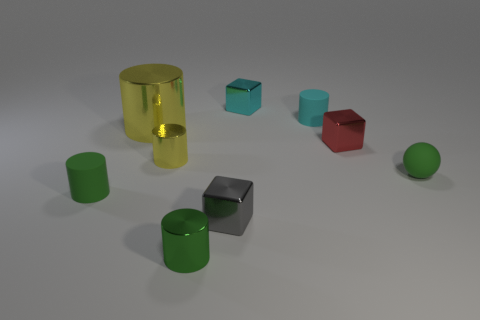Subtract all large yellow cylinders. How many cylinders are left? 4 Subtract all red cubes. How many cubes are left? 2 Subtract all brown blocks. How many green cylinders are left? 2 Subtract all balls. How many objects are left? 8 Subtract 2 cylinders. How many cylinders are left? 3 Subtract all red cylinders. Subtract all gray blocks. How many cylinders are left? 5 Subtract all tiny red blocks. Subtract all cyan metallic cubes. How many objects are left? 7 Add 6 red blocks. How many red blocks are left? 7 Add 9 large objects. How many large objects exist? 10 Subtract 0 green blocks. How many objects are left? 9 